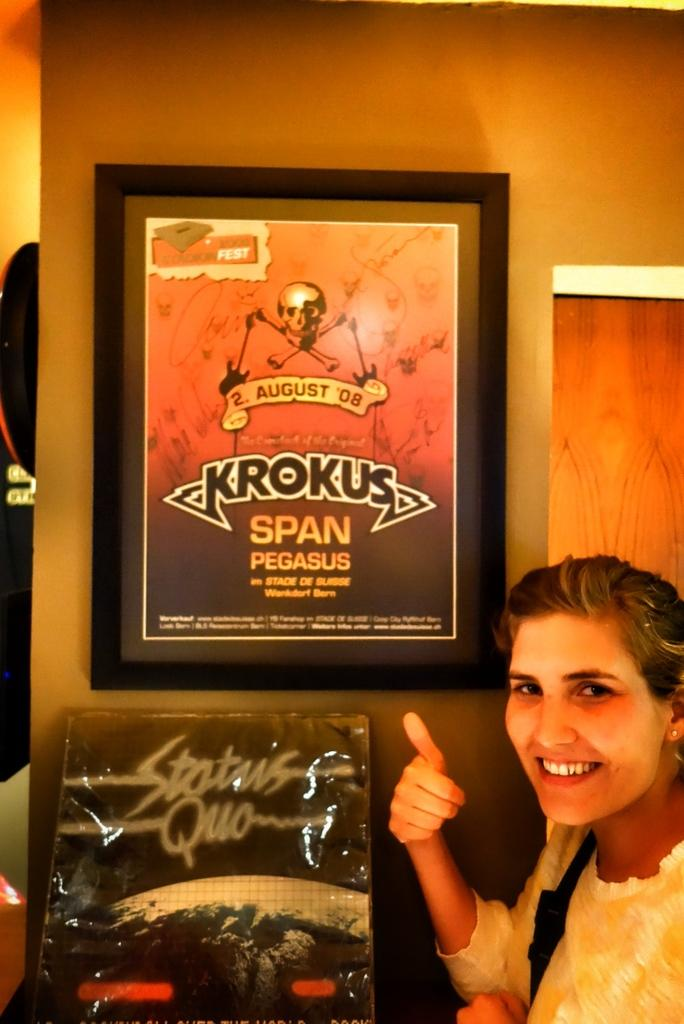What is present in the image? There is a person in the image. Can you describe the person's attire? The person is wearing clothes. What can be seen on the wall in the image? There is a photo frame on the wall. What is located at the bottom of the image? There is a cardboard sheet at the bottom of the image. What type of worm can be seen crawling on the person's clothes in the image? There is no worm present in the image; the person is wearing clothes, but no worms are visible. 